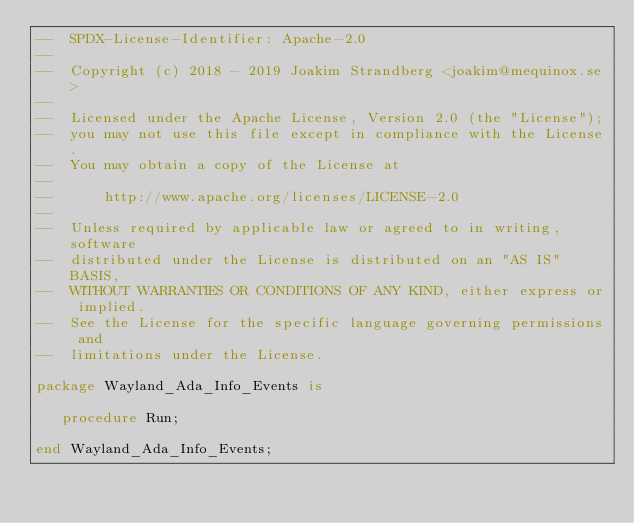<code> <loc_0><loc_0><loc_500><loc_500><_Ada_>--  SPDX-License-Identifier: Apache-2.0
--
--  Copyright (c) 2018 - 2019 Joakim Strandberg <joakim@mequinox.se>
--
--  Licensed under the Apache License, Version 2.0 (the "License");
--  you may not use this file except in compliance with the License.
--  You may obtain a copy of the License at
--
--      http://www.apache.org/licenses/LICENSE-2.0
--
--  Unless required by applicable law or agreed to in writing, software
--  distributed under the License is distributed on an "AS IS" BASIS,
--  WITHOUT WARRANTIES OR CONDITIONS OF ANY KIND, either express or implied.
--  See the License for the specific language governing permissions and
--  limitations under the License.

package Wayland_Ada_Info_Events is

   procedure Run;

end Wayland_Ada_Info_Events;
</code> 